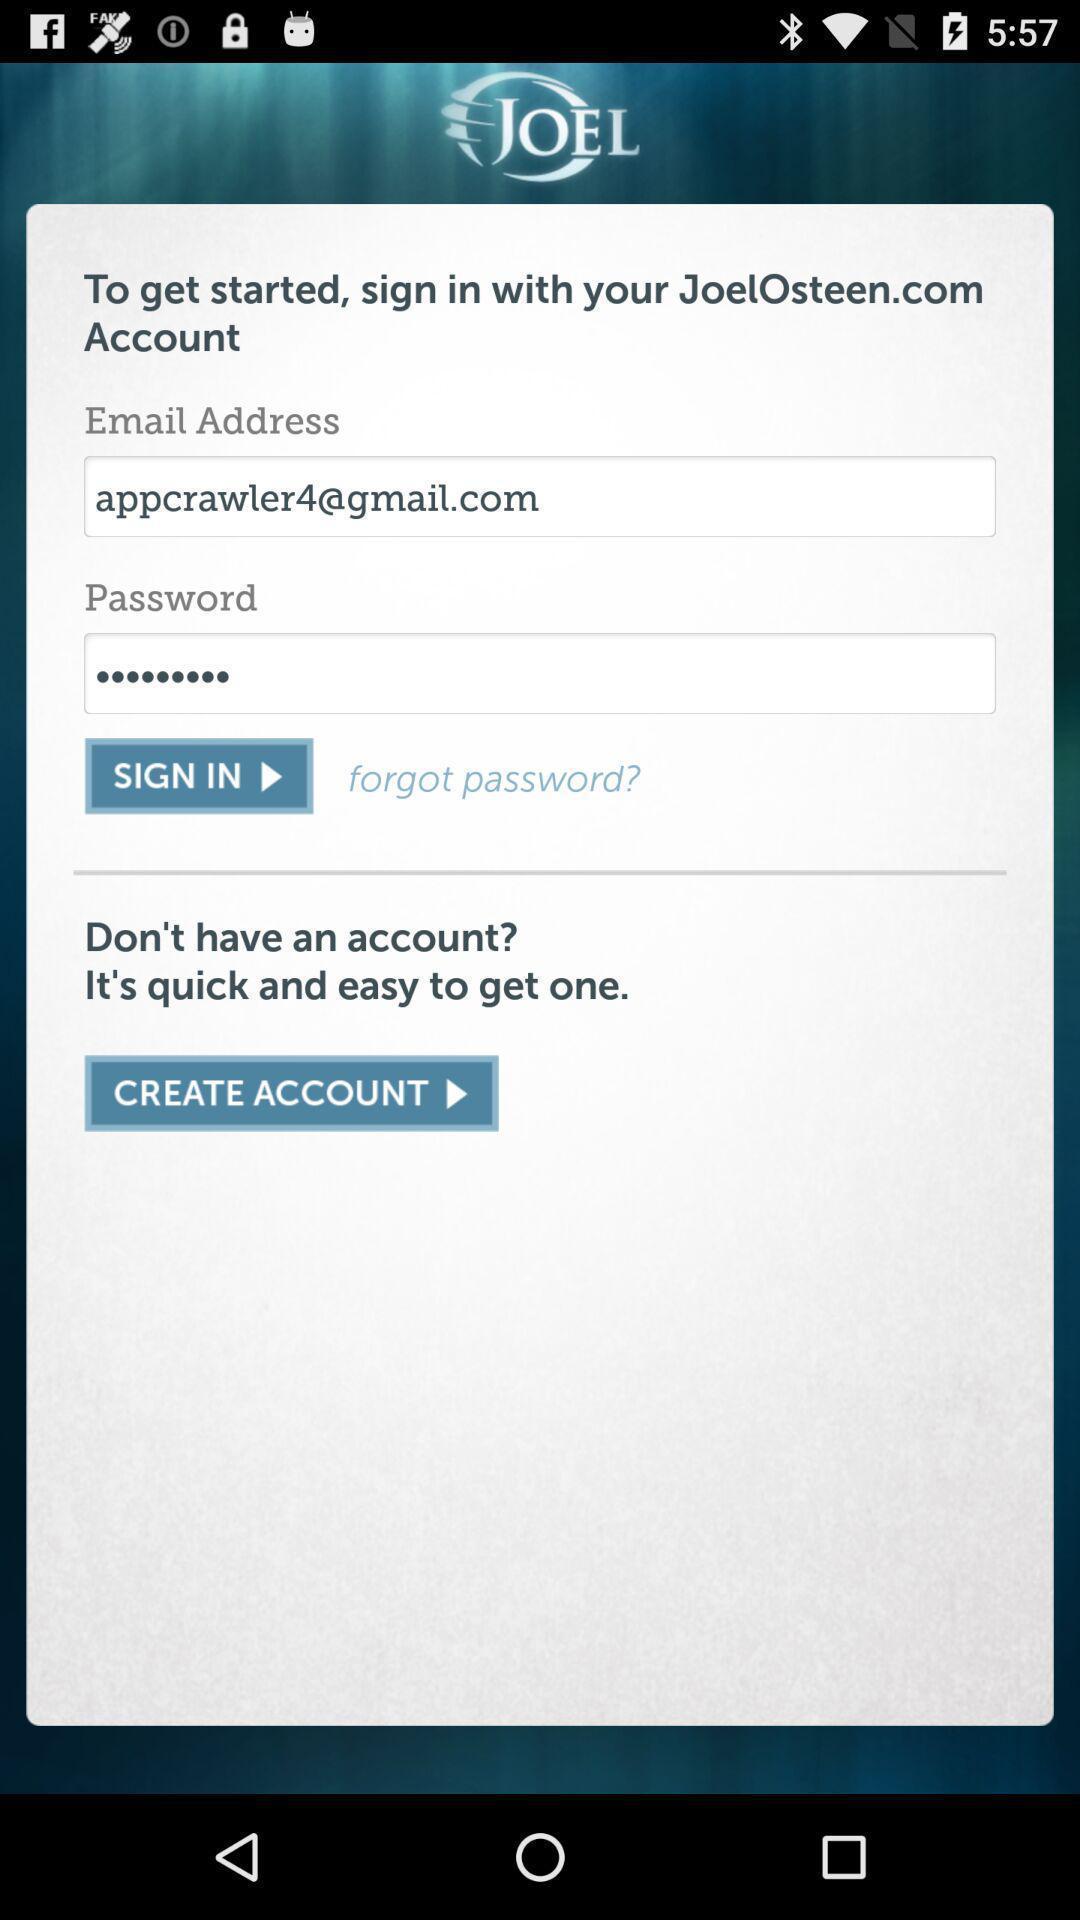What details can you identify in this image? Sign up page. 